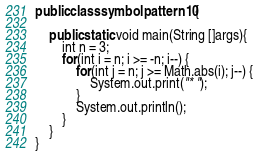<code> <loc_0><loc_0><loc_500><loc_500><_Java_>public class symbolpattern10 {

    public static void main(String []args){
        int n = 3;
        for(int i = n; i >= -n; i--) {
            for(int j = n; j >= Math.abs(i); j--) {
                System.out.print("* ");
            }
            System.out.println();
        }    
    }
}</code> 